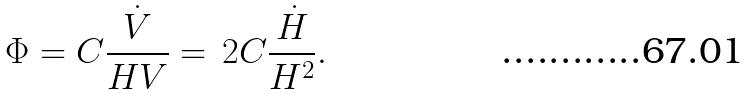<formula> <loc_0><loc_0><loc_500><loc_500>\Phi = C \frac { \dot { V } } { H V } = \, 2 C \frac { \dot { H } } { H ^ { 2 } } .</formula> 